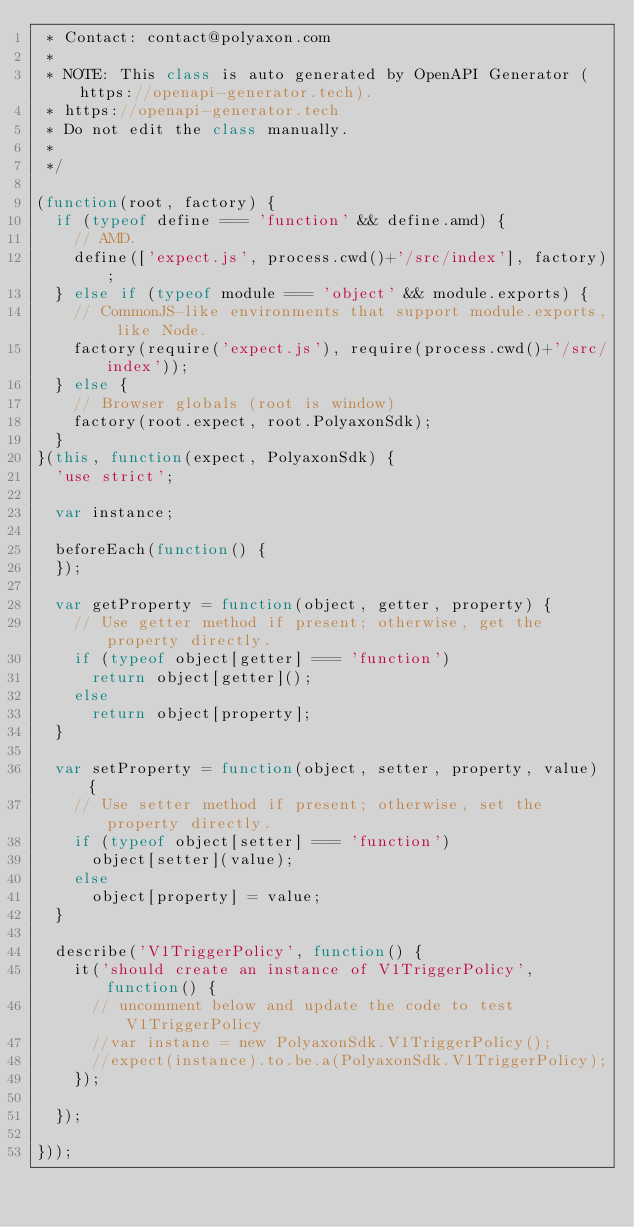Convert code to text. <code><loc_0><loc_0><loc_500><loc_500><_JavaScript_> * Contact: contact@polyaxon.com
 *
 * NOTE: This class is auto generated by OpenAPI Generator (https://openapi-generator.tech).
 * https://openapi-generator.tech
 * Do not edit the class manually.
 *
 */

(function(root, factory) {
  if (typeof define === 'function' && define.amd) {
    // AMD.
    define(['expect.js', process.cwd()+'/src/index'], factory);
  } else if (typeof module === 'object' && module.exports) {
    // CommonJS-like environments that support module.exports, like Node.
    factory(require('expect.js'), require(process.cwd()+'/src/index'));
  } else {
    // Browser globals (root is window)
    factory(root.expect, root.PolyaxonSdk);
  }
}(this, function(expect, PolyaxonSdk) {
  'use strict';

  var instance;

  beforeEach(function() {
  });

  var getProperty = function(object, getter, property) {
    // Use getter method if present; otherwise, get the property directly.
    if (typeof object[getter] === 'function')
      return object[getter]();
    else
      return object[property];
  }

  var setProperty = function(object, setter, property, value) {
    // Use setter method if present; otherwise, set the property directly.
    if (typeof object[setter] === 'function')
      object[setter](value);
    else
      object[property] = value;
  }

  describe('V1TriggerPolicy', function() {
    it('should create an instance of V1TriggerPolicy', function() {
      // uncomment below and update the code to test V1TriggerPolicy
      //var instane = new PolyaxonSdk.V1TriggerPolicy();
      //expect(instance).to.be.a(PolyaxonSdk.V1TriggerPolicy);
    });

  });

}));
</code> 